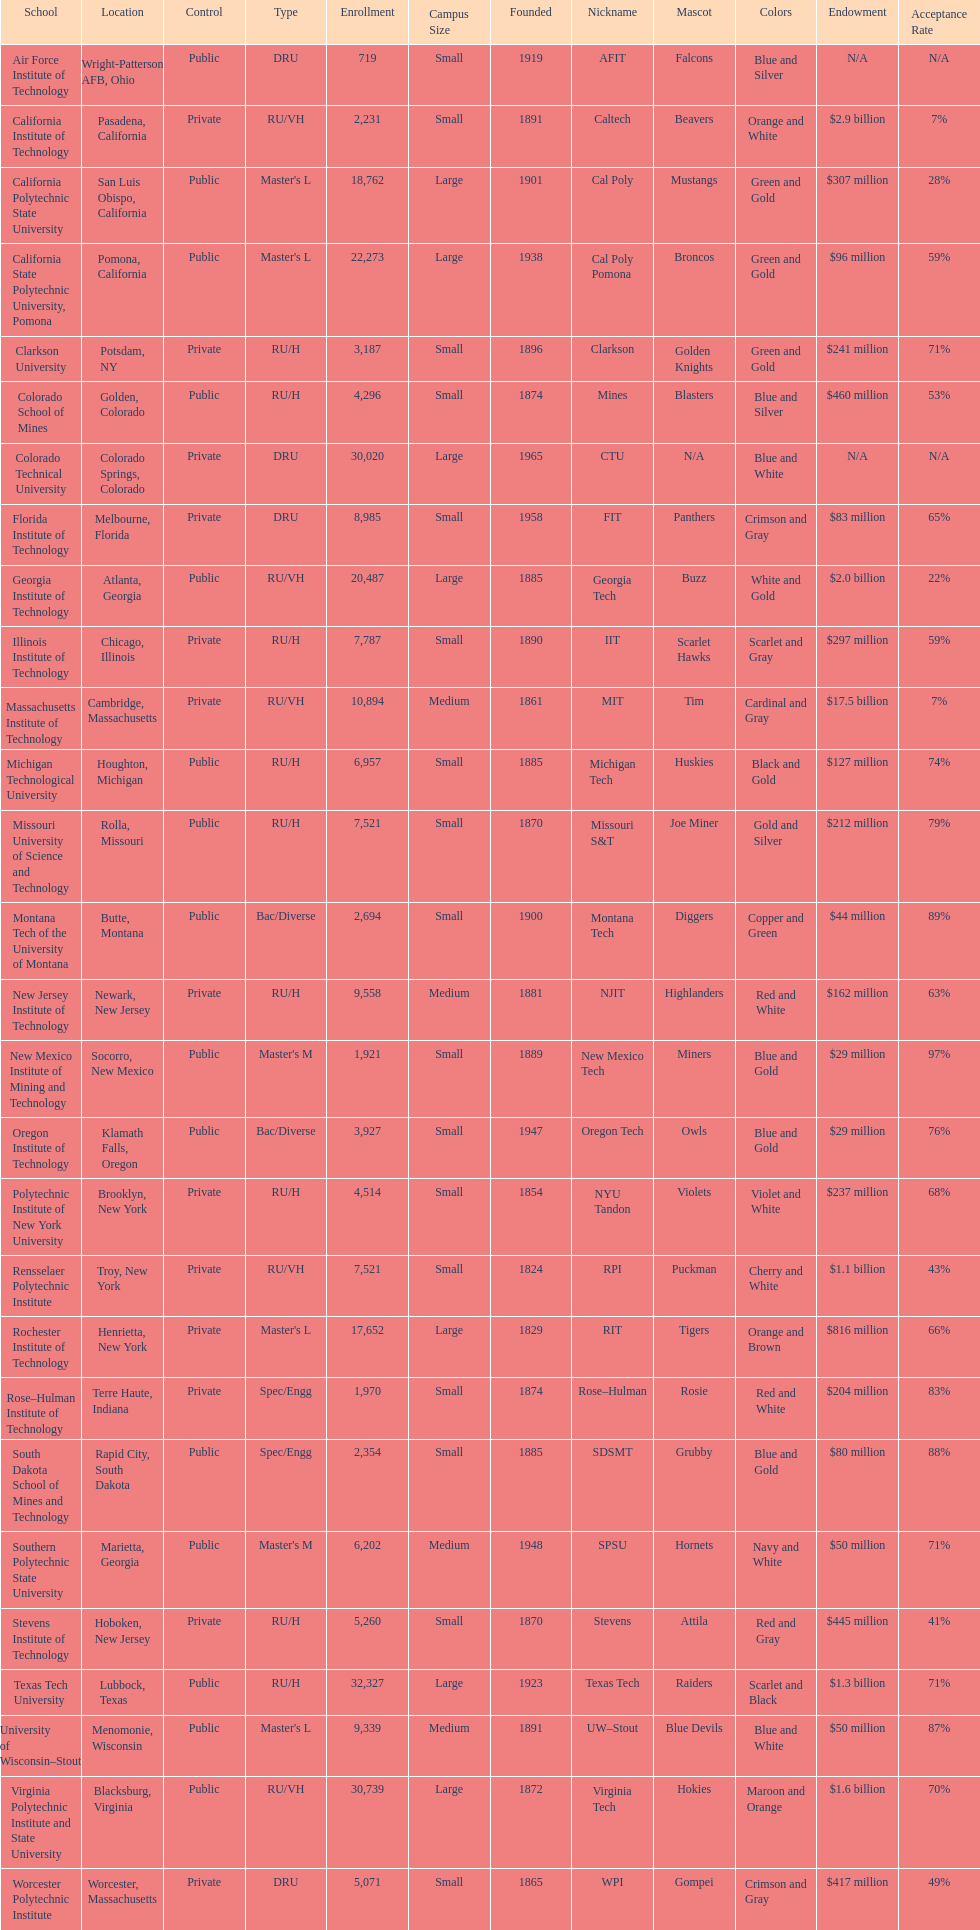What educational institution is mentioned following michigan technological university? Missouri University of Science and Technology. 